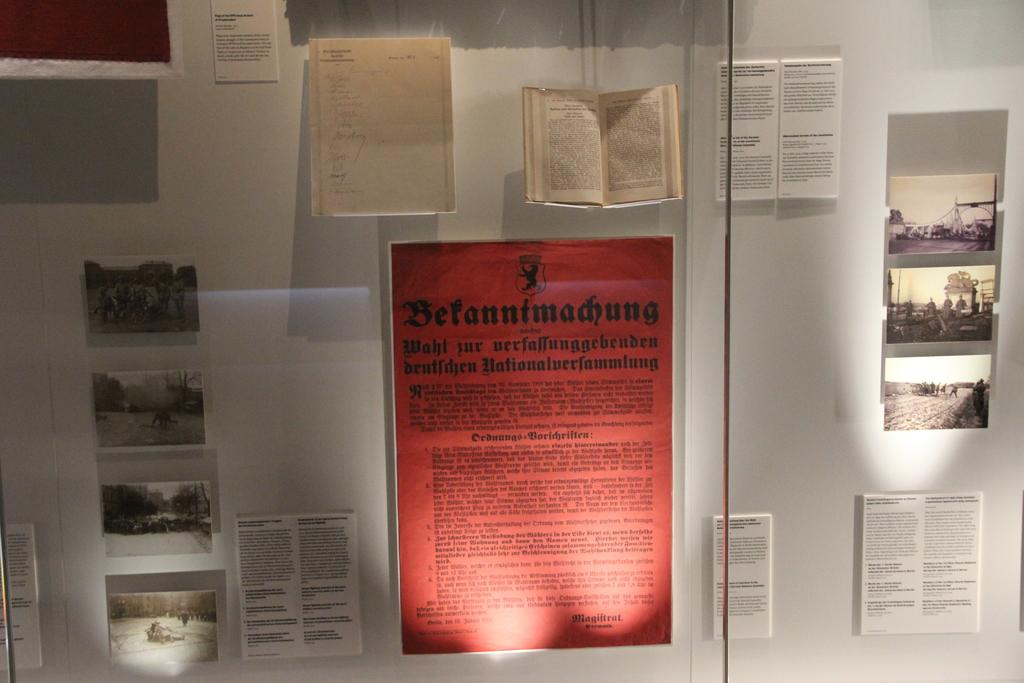<image>
Present a compact description of the photo's key features. a series of papers on the wall with one of them that says 'befannfmadiung' on it 